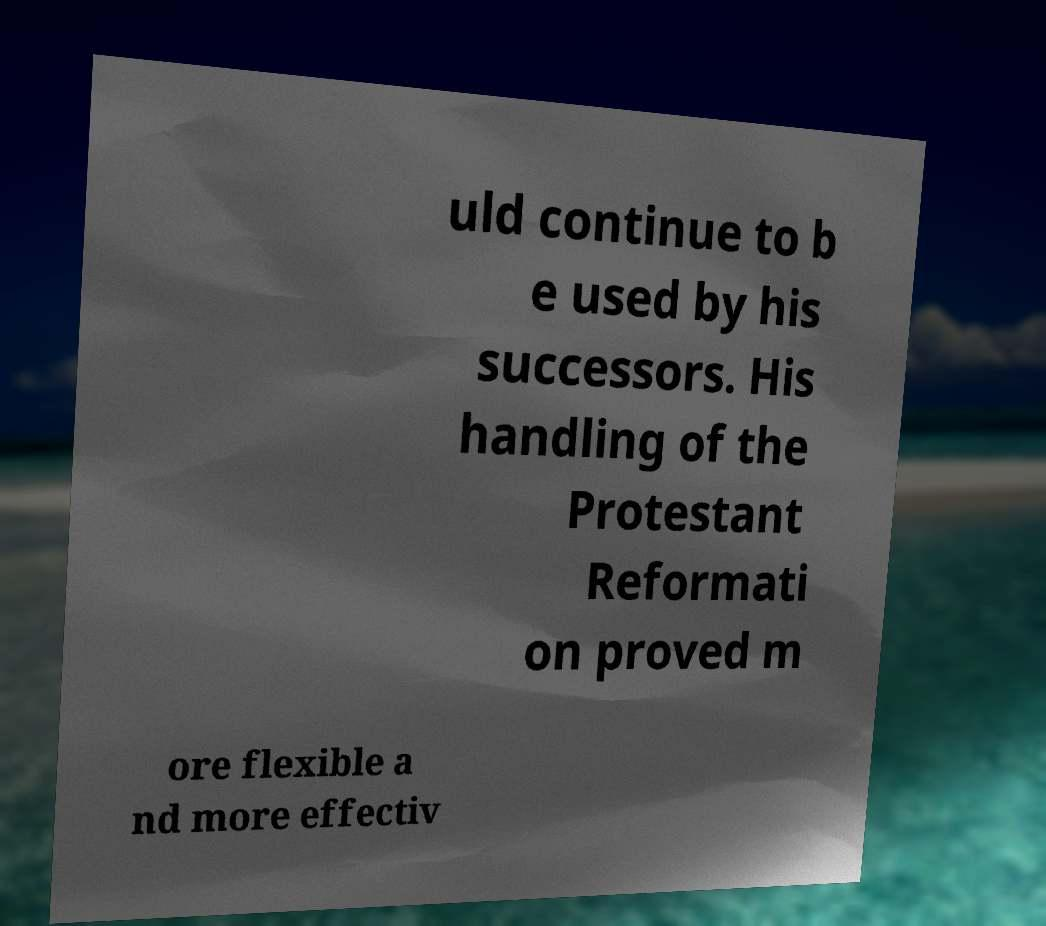Could you assist in decoding the text presented in this image and type it out clearly? uld continue to b e used by his successors. His handling of the Protestant Reformati on proved m ore flexible a nd more effectiv 